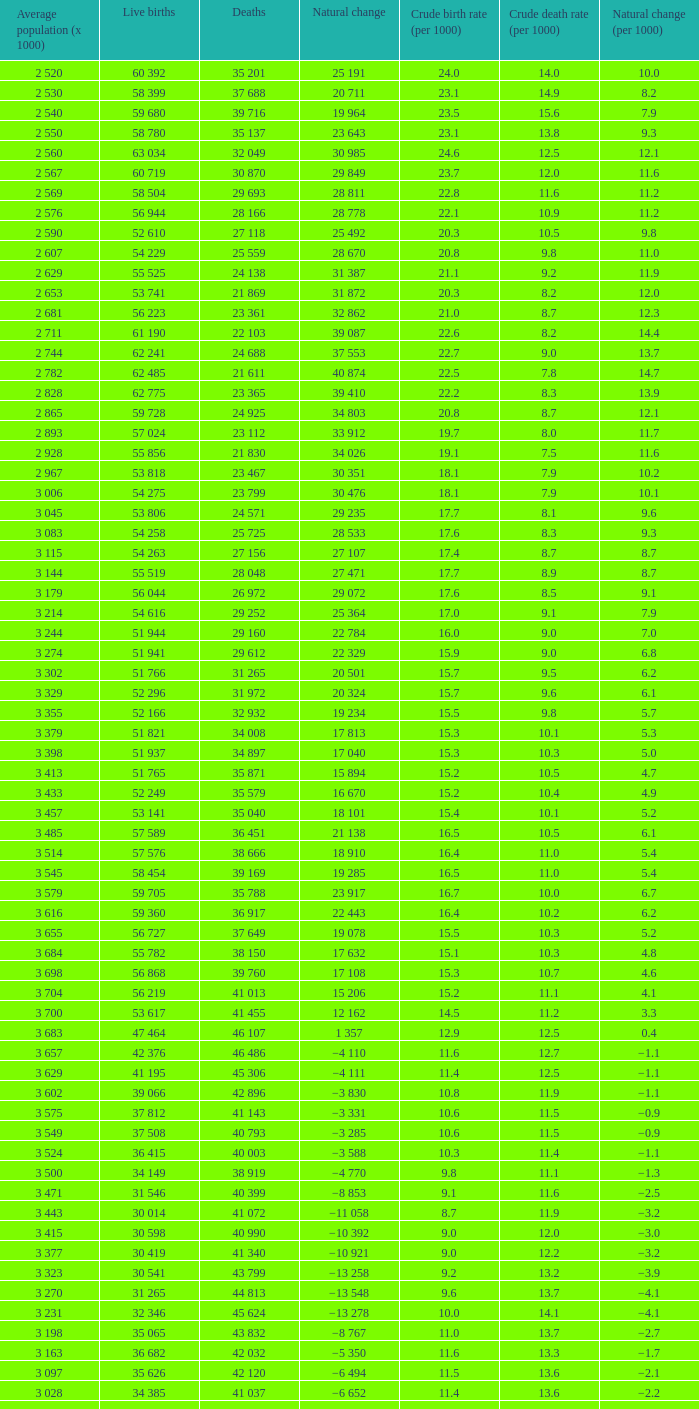Which mean population (x 1000) has a crude mortality rate (per 1000) less than 1 3 115. 